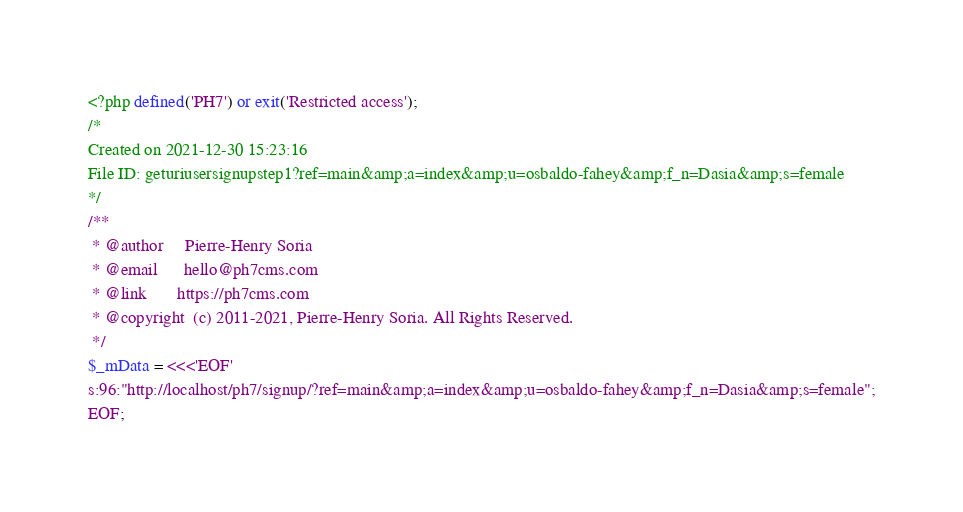Convert code to text. <code><loc_0><loc_0><loc_500><loc_500><_PHP_><?php defined('PH7') or exit('Restricted access');
/*
Created on 2021-12-30 15:23:16
File ID: geturiusersignupstep1?ref=main&amp;a=index&amp;u=osbaldo-fahey&amp;f_n=Dasia&amp;s=female
*/
/**
 * @author     Pierre-Henry Soria
 * @email      hello@ph7cms.com
 * @link       https://ph7cms.com
 * @copyright  (c) 2011-2021, Pierre-Henry Soria. All Rights Reserved.
 */
$_mData = <<<'EOF'
s:96:"http://localhost/ph7/signup/?ref=main&amp;a=index&amp;u=osbaldo-fahey&amp;f_n=Dasia&amp;s=female";
EOF;
</code> 